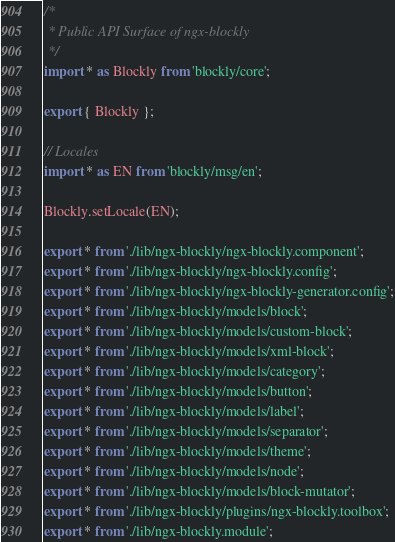Convert code to text. <code><loc_0><loc_0><loc_500><loc_500><_TypeScript_>/*
 * Public API Surface of ngx-blockly
 */
import * as Blockly from 'blockly/core';

export { Blockly };

// Locales
import * as EN from 'blockly/msg/en';

Blockly.setLocale(EN);

export * from './lib/ngx-blockly/ngx-blockly.component';
export * from './lib/ngx-blockly/ngx-blockly.config';
export * from './lib/ngx-blockly/ngx-blockly-generator.config';
export * from './lib/ngx-blockly/models/block';
export * from './lib/ngx-blockly/models/custom-block';
export * from './lib/ngx-blockly/models/xml-block';
export * from './lib/ngx-blockly/models/category';
export * from './lib/ngx-blockly/models/button';
export * from './lib/ngx-blockly/models/label';
export * from './lib/ngx-blockly/models/separator';
export * from './lib/ngx-blockly/models/theme';
export * from './lib/ngx-blockly/models/node';
export * from './lib/ngx-blockly/models/block-mutator';
export * from './lib/ngx-blockly/plugins/ngx-blockly.toolbox';
export * from './lib/ngx-blockly.module';










</code> 